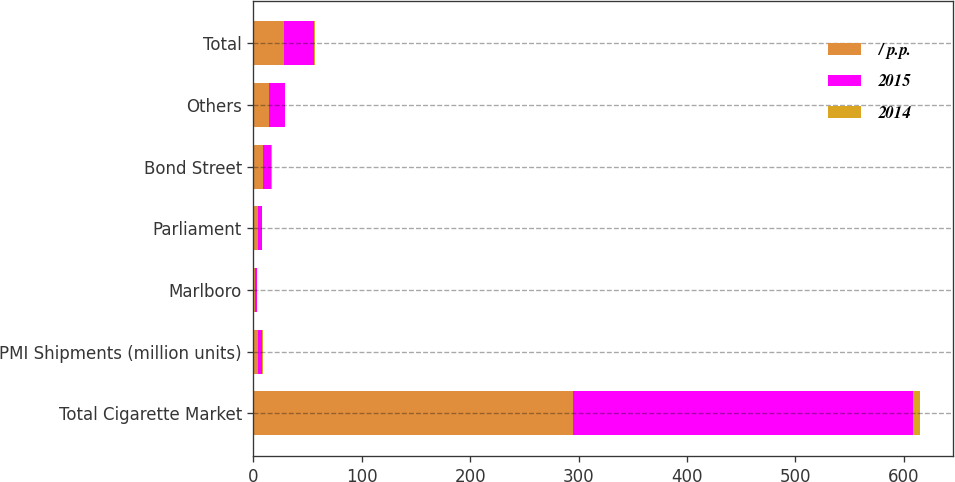<chart> <loc_0><loc_0><loc_500><loc_500><stacked_bar_chart><ecel><fcel>Total Cigarette Market<fcel>PMI Shipments (million units)<fcel>Marlboro<fcel>Parliament<fcel>Bond Street<fcel>Others<fcel>Total<nl><fcel>/ p.p.<fcel>294.5<fcel>3.9<fcel>1.4<fcel>3.9<fcel>8.4<fcel>14.7<fcel>28.4<nl><fcel>2015<fcel>314.1<fcel>3.9<fcel>1.6<fcel>3.7<fcel>7.7<fcel>14.5<fcel>27.5<nl><fcel>2014<fcel>6.2<fcel>0.6<fcel>0.2<fcel>0.2<fcel>0.7<fcel>0.2<fcel>0.9<nl></chart> 